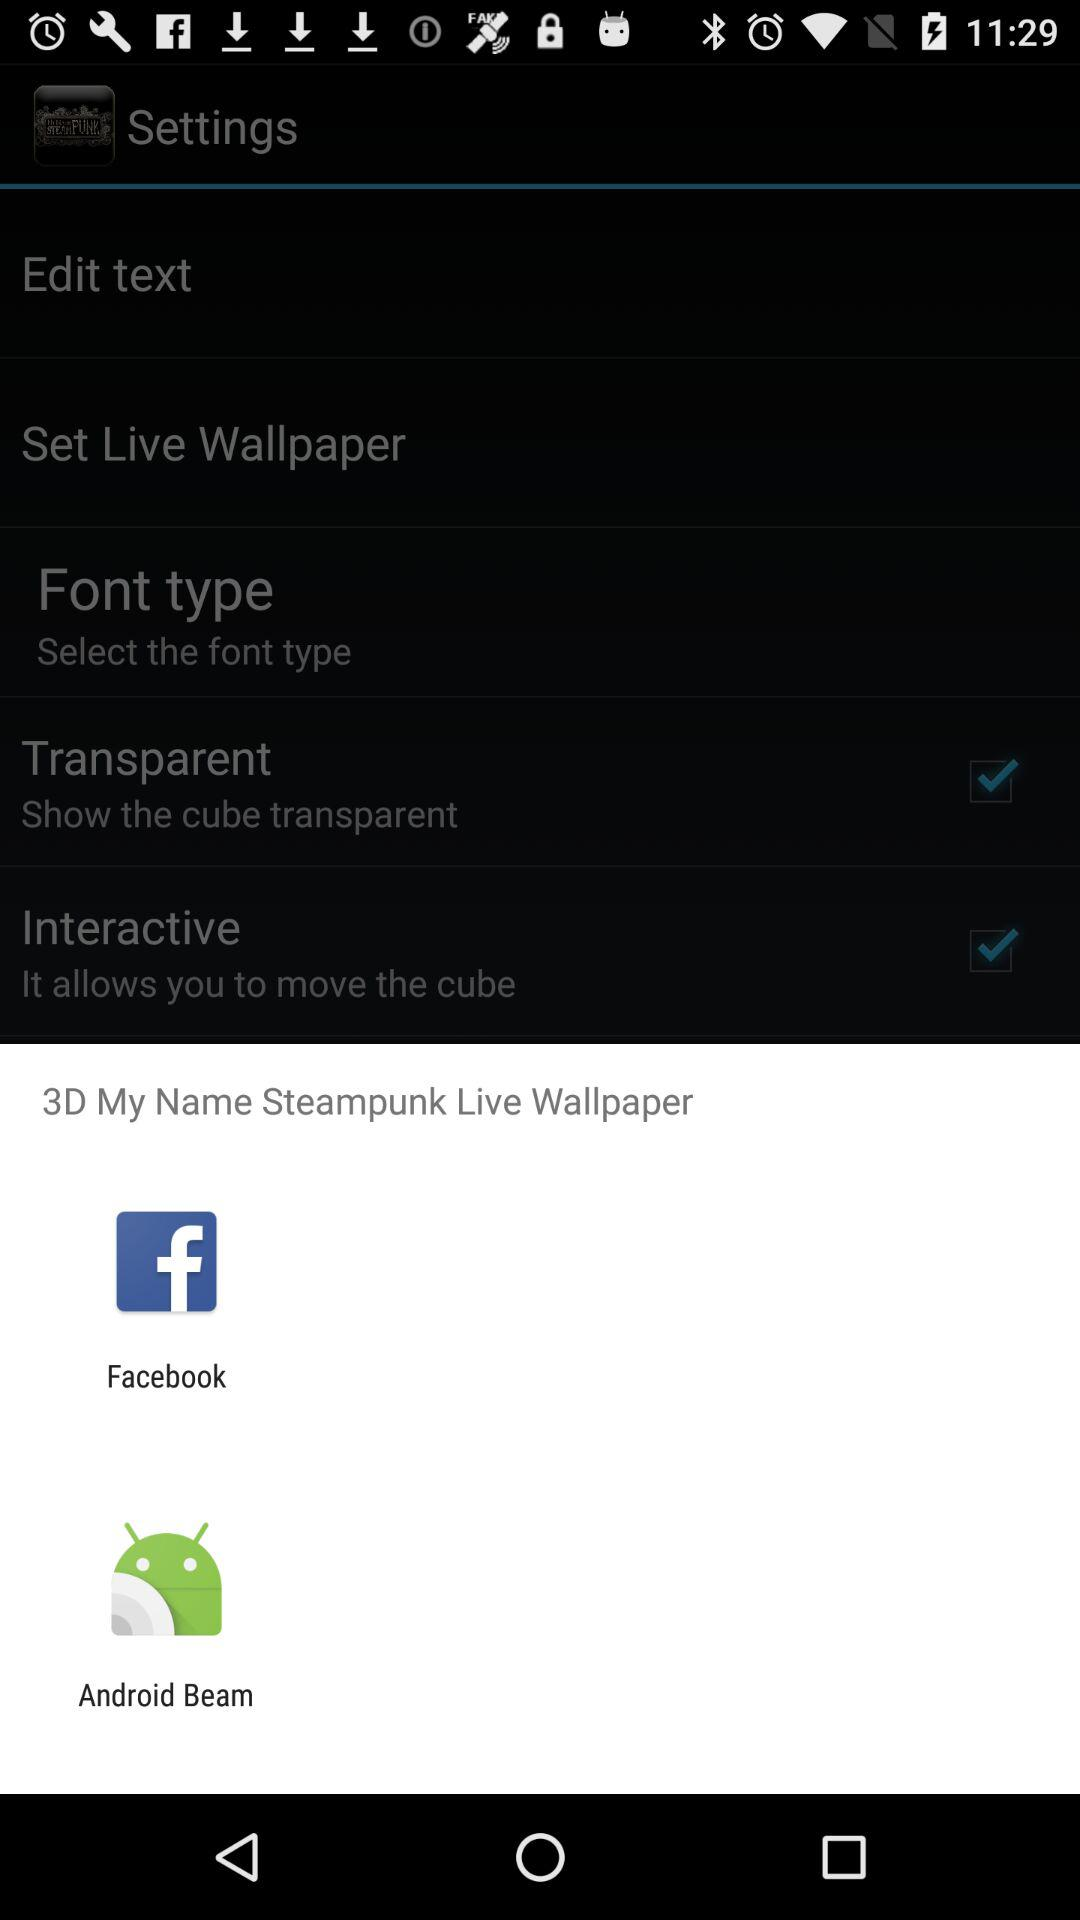Which options are given to share the "3D My Name Steampunk Live Wallpaper"? The given options are "Facebook" and "Android Beam". 